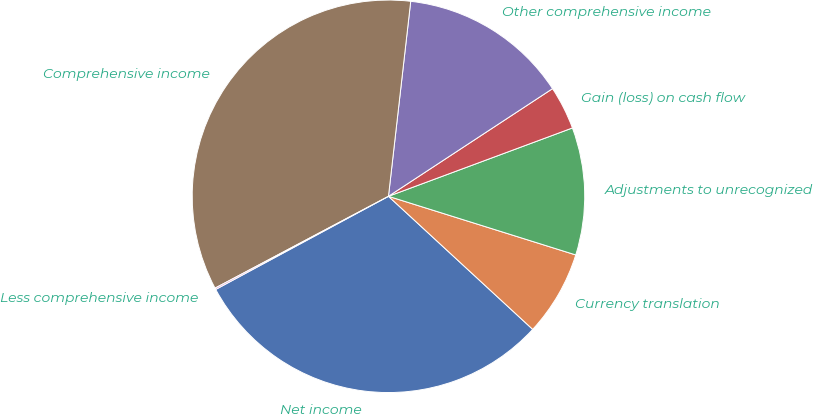Convert chart to OTSL. <chart><loc_0><loc_0><loc_500><loc_500><pie_chart><fcel>Net income<fcel>Currency translation<fcel>Adjustments to unrecognized<fcel>Gain (loss) on cash flow<fcel>Other comprehensive income<fcel>Comprehensive income<fcel>Less comprehensive income<nl><fcel>30.27%<fcel>7.03%<fcel>10.49%<fcel>3.58%<fcel>13.95%<fcel>34.56%<fcel>0.12%<nl></chart> 